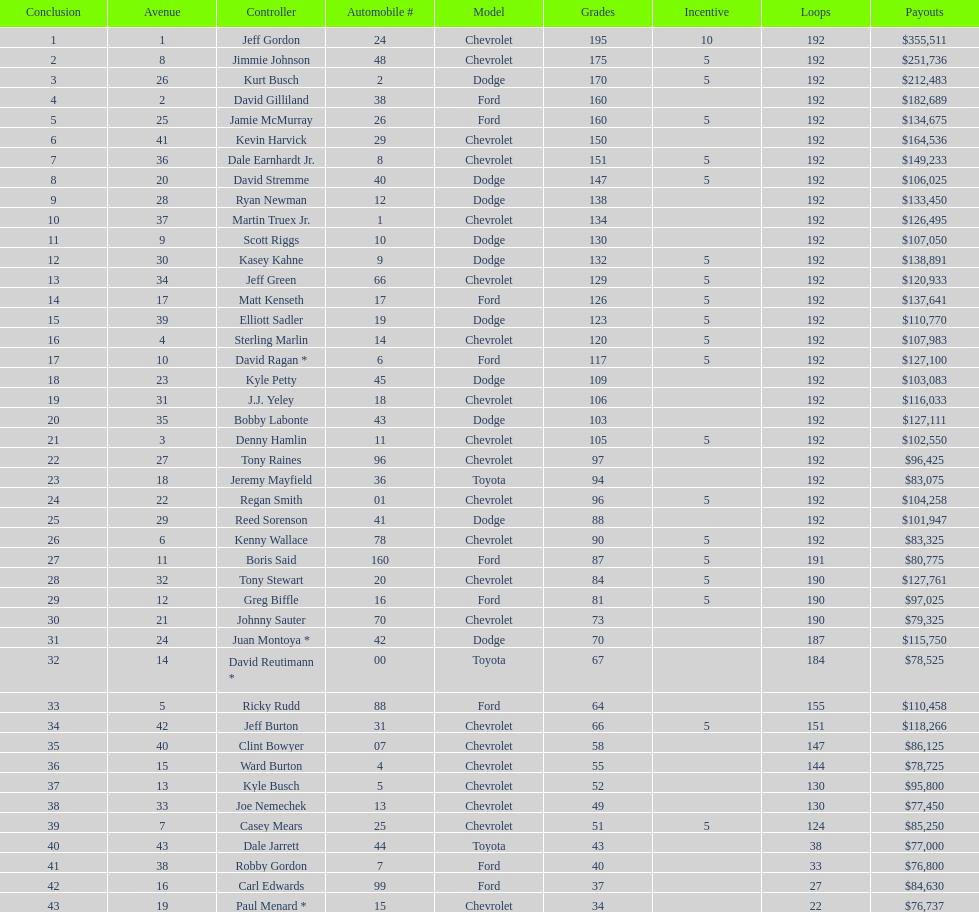I'm looking to parse the entire table for insights. Could you assist me with that? {'header': ['Conclusion', 'Avenue', 'Controller', 'Automobile #', 'Model', 'Grades', 'Incentive', 'Loops', 'Payouts'], 'rows': [['1', '1', 'Jeff Gordon', '24', 'Chevrolet', '195', '10', '192', '$355,511'], ['2', '8', 'Jimmie Johnson', '48', 'Chevrolet', '175', '5', '192', '$251,736'], ['3', '26', 'Kurt Busch', '2', 'Dodge', '170', '5', '192', '$212,483'], ['4', '2', 'David Gilliland', '38', 'Ford', '160', '', '192', '$182,689'], ['5', '25', 'Jamie McMurray', '26', 'Ford', '160', '5', '192', '$134,675'], ['6', '41', 'Kevin Harvick', '29', 'Chevrolet', '150', '', '192', '$164,536'], ['7', '36', 'Dale Earnhardt Jr.', '8', 'Chevrolet', '151', '5', '192', '$149,233'], ['8', '20', 'David Stremme', '40', 'Dodge', '147', '5', '192', '$106,025'], ['9', '28', 'Ryan Newman', '12', 'Dodge', '138', '', '192', '$133,450'], ['10', '37', 'Martin Truex Jr.', '1', 'Chevrolet', '134', '', '192', '$126,495'], ['11', '9', 'Scott Riggs', '10', 'Dodge', '130', '', '192', '$107,050'], ['12', '30', 'Kasey Kahne', '9', 'Dodge', '132', '5', '192', '$138,891'], ['13', '34', 'Jeff Green', '66', 'Chevrolet', '129', '5', '192', '$120,933'], ['14', '17', 'Matt Kenseth', '17', 'Ford', '126', '5', '192', '$137,641'], ['15', '39', 'Elliott Sadler', '19', 'Dodge', '123', '5', '192', '$110,770'], ['16', '4', 'Sterling Marlin', '14', 'Chevrolet', '120', '5', '192', '$107,983'], ['17', '10', 'David Ragan *', '6', 'Ford', '117', '5', '192', '$127,100'], ['18', '23', 'Kyle Petty', '45', 'Dodge', '109', '', '192', '$103,083'], ['19', '31', 'J.J. Yeley', '18', 'Chevrolet', '106', '', '192', '$116,033'], ['20', '35', 'Bobby Labonte', '43', 'Dodge', '103', '', '192', '$127,111'], ['21', '3', 'Denny Hamlin', '11', 'Chevrolet', '105', '5', '192', '$102,550'], ['22', '27', 'Tony Raines', '96', 'Chevrolet', '97', '', '192', '$96,425'], ['23', '18', 'Jeremy Mayfield', '36', 'Toyota', '94', '', '192', '$83,075'], ['24', '22', 'Regan Smith', '01', 'Chevrolet', '96', '5', '192', '$104,258'], ['25', '29', 'Reed Sorenson', '41', 'Dodge', '88', '', '192', '$101,947'], ['26', '6', 'Kenny Wallace', '78', 'Chevrolet', '90', '5', '192', '$83,325'], ['27', '11', 'Boris Said', '160', 'Ford', '87', '5', '191', '$80,775'], ['28', '32', 'Tony Stewart', '20', 'Chevrolet', '84', '5', '190', '$127,761'], ['29', '12', 'Greg Biffle', '16', 'Ford', '81', '5', '190', '$97,025'], ['30', '21', 'Johnny Sauter', '70', 'Chevrolet', '73', '', '190', '$79,325'], ['31', '24', 'Juan Montoya *', '42', 'Dodge', '70', '', '187', '$115,750'], ['32', '14', 'David Reutimann *', '00', 'Toyota', '67', '', '184', '$78,525'], ['33', '5', 'Ricky Rudd', '88', 'Ford', '64', '', '155', '$110,458'], ['34', '42', 'Jeff Burton', '31', 'Chevrolet', '66', '5', '151', '$118,266'], ['35', '40', 'Clint Bowyer', '07', 'Chevrolet', '58', '', '147', '$86,125'], ['36', '15', 'Ward Burton', '4', 'Chevrolet', '55', '', '144', '$78,725'], ['37', '13', 'Kyle Busch', '5', 'Chevrolet', '52', '', '130', '$95,800'], ['38', '33', 'Joe Nemechek', '13', 'Chevrolet', '49', '', '130', '$77,450'], ['39', '7', 'Casey Mears', '25', 'Chevrolet', '51', '5', '124', '$85,250'], ['40', '43', 'Dale Jarrett', '44', 'Toyota', '43', '', '38', '$77,000'], ['41', '38', 'Robby Gordon', '7', 'Ford', '40', '', '33', '$76,800'], ['42', '16', 'Carl Edwards', '99', 'Ford', '37', '', '27', '$84,630'], ['43', '19', 'Paul Menard *', '15', 'Chevrolet', '34', '', '22', '$76,737']]} How many drivers earned 5 bonus each in the race? 19. 